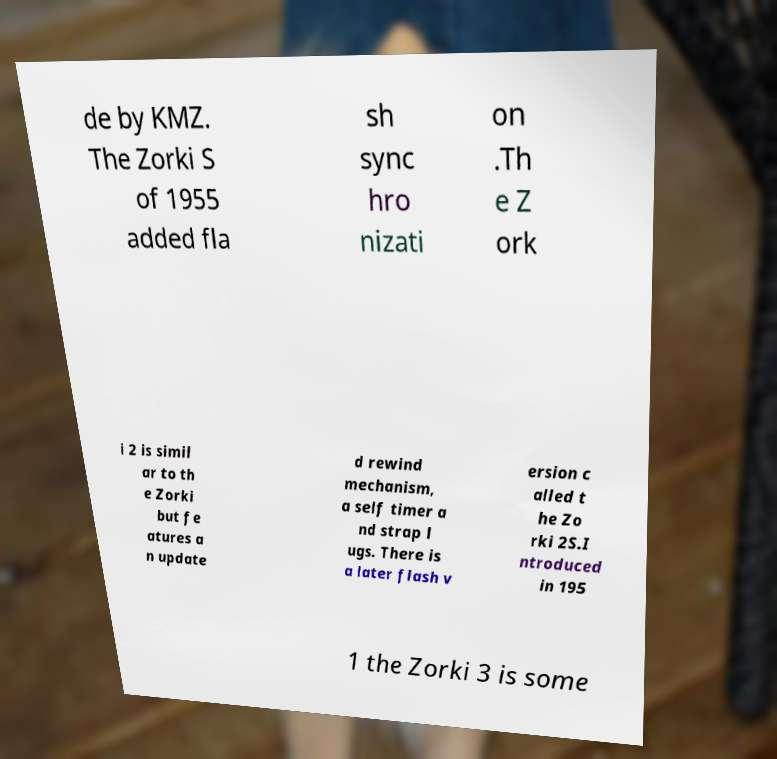Could you extract and type out the text from this image? de by KMZ. The Zorki S of 1955 added fla sh sync hro nizati on .Th e Z ork i 2 is simil ar to th e Zorki but fe atures a n update d rewind mechanism, a self timer a nd strap l ugs. There is a later flash v ersion c alled t he Zo rki 2S.I ntroduced in 195 1 the Zorki 3 is some 